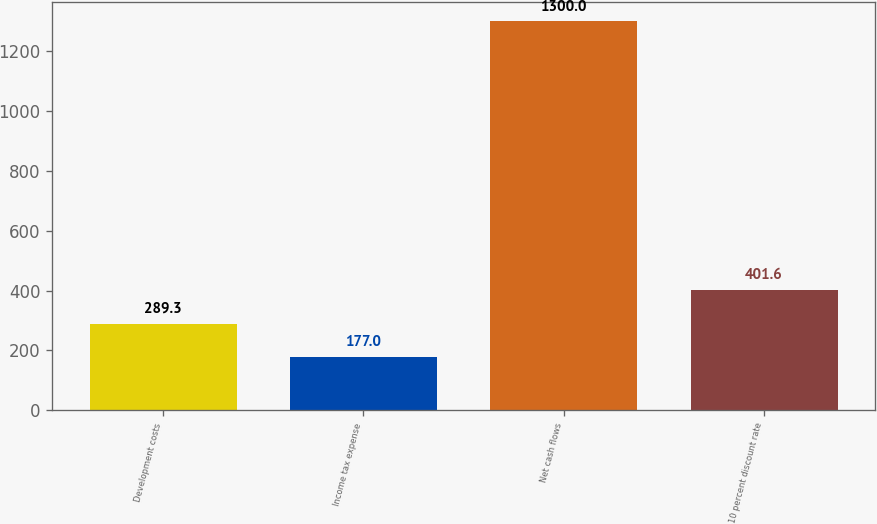Convert chart to OTSL. <chart><loc_0><loc_0><loc_500><loc_500><bar_chart><fcel>Development costs<fcel>Income tax expense<fcel>Net cash flows<fcel>10 percent discount rate<nl><fcel>289.3<fcel>177<fcel>1300<fcel>401.6<nl></chart> 